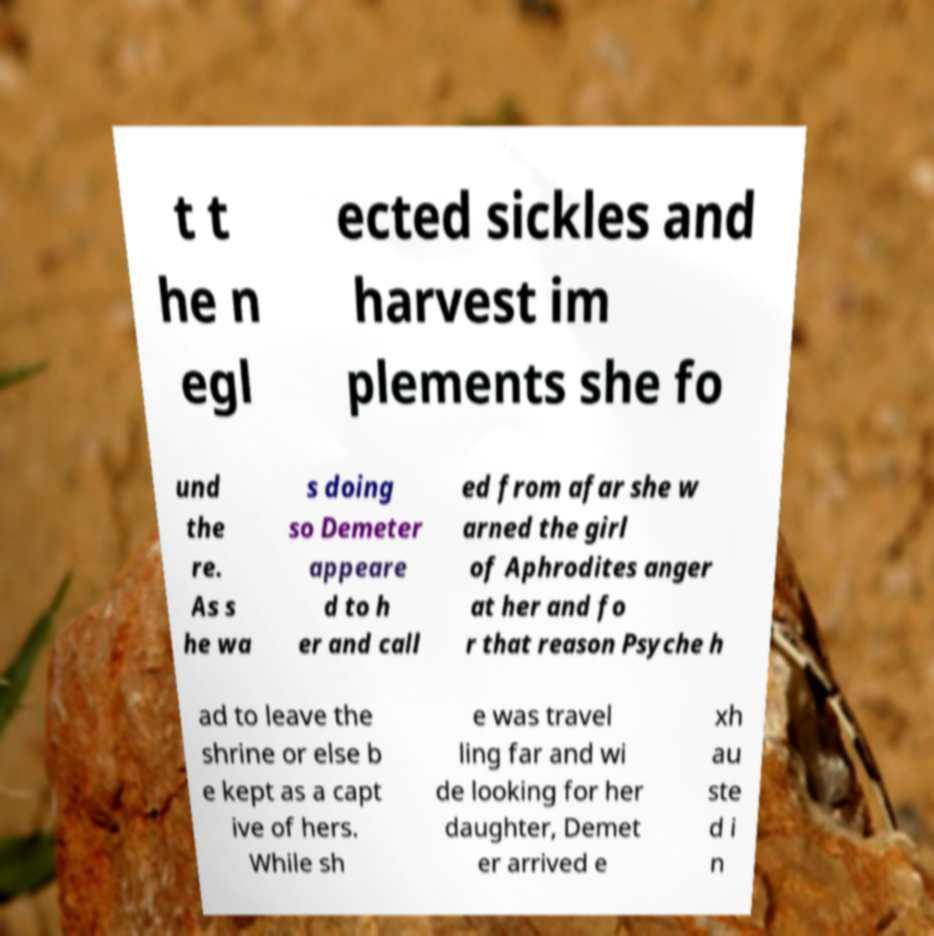What messages or text are displayed in this image? I need them in a readable, typed format. t t he n egl ected sickles and harvest im plements she fo und the re. As s he wa s doing so Demeter appeare d to h er and call ed from afar she w arned the girl of Aphrodites anger at her and fo r that reason Psyche h ad to leave the shrine or else b e kept as a capt ive of hers. While sh e was travel ling far and wi de looking for her daughter, Demet er arrived e xh au ste d i n 